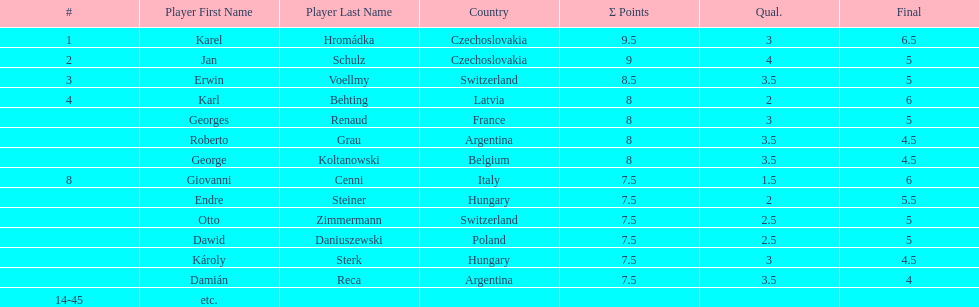Did the two competitors from hungary get more or less combined points than the two competitors from argentina? Less. 